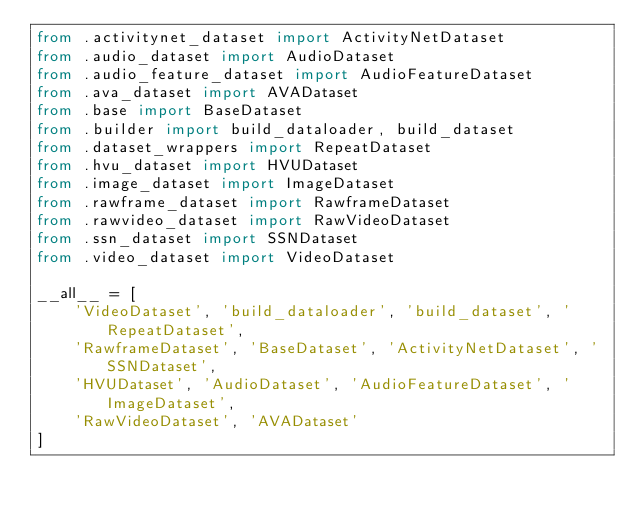Convert code to text. <code><loc_0><loc_0><loc_500><loc_500><_Python_>from .activitynet_dataset import ActivityNetDataset
from .audio_dataset import AudioDataset
from .audio_feature_dataset import AudioFeatureDataset
from .ava_dataset import AVADataset
from .base import BaseDataset
from .builder import build_dataloader, build_dataset
from .dataset_wrappers import RepeatDataset
from .hvu_dataset import HVUDataset
from .image_dataset import ImageDataset
from .rawframe_dataset import RawframeDataset
from .rawvideo_dataset import RawVideoDataset
from .ssn_dataset import SSNDataset
from .video_dataset import VideoDataset

__all__ = [
    'VideoDataset', 'build_dataloader', 'build_dataset', 'RepeatDataset',
    'RawframeDataset', 'BaseDataset', 'ActivityNetDataset', 'SSNDataset',
    'HVUDataset', 'AudioDataset', 'AudioFeatureDataset', 'ImageDataset',
    'RawVideoDataset', 'AVADataset'
]
</code> 